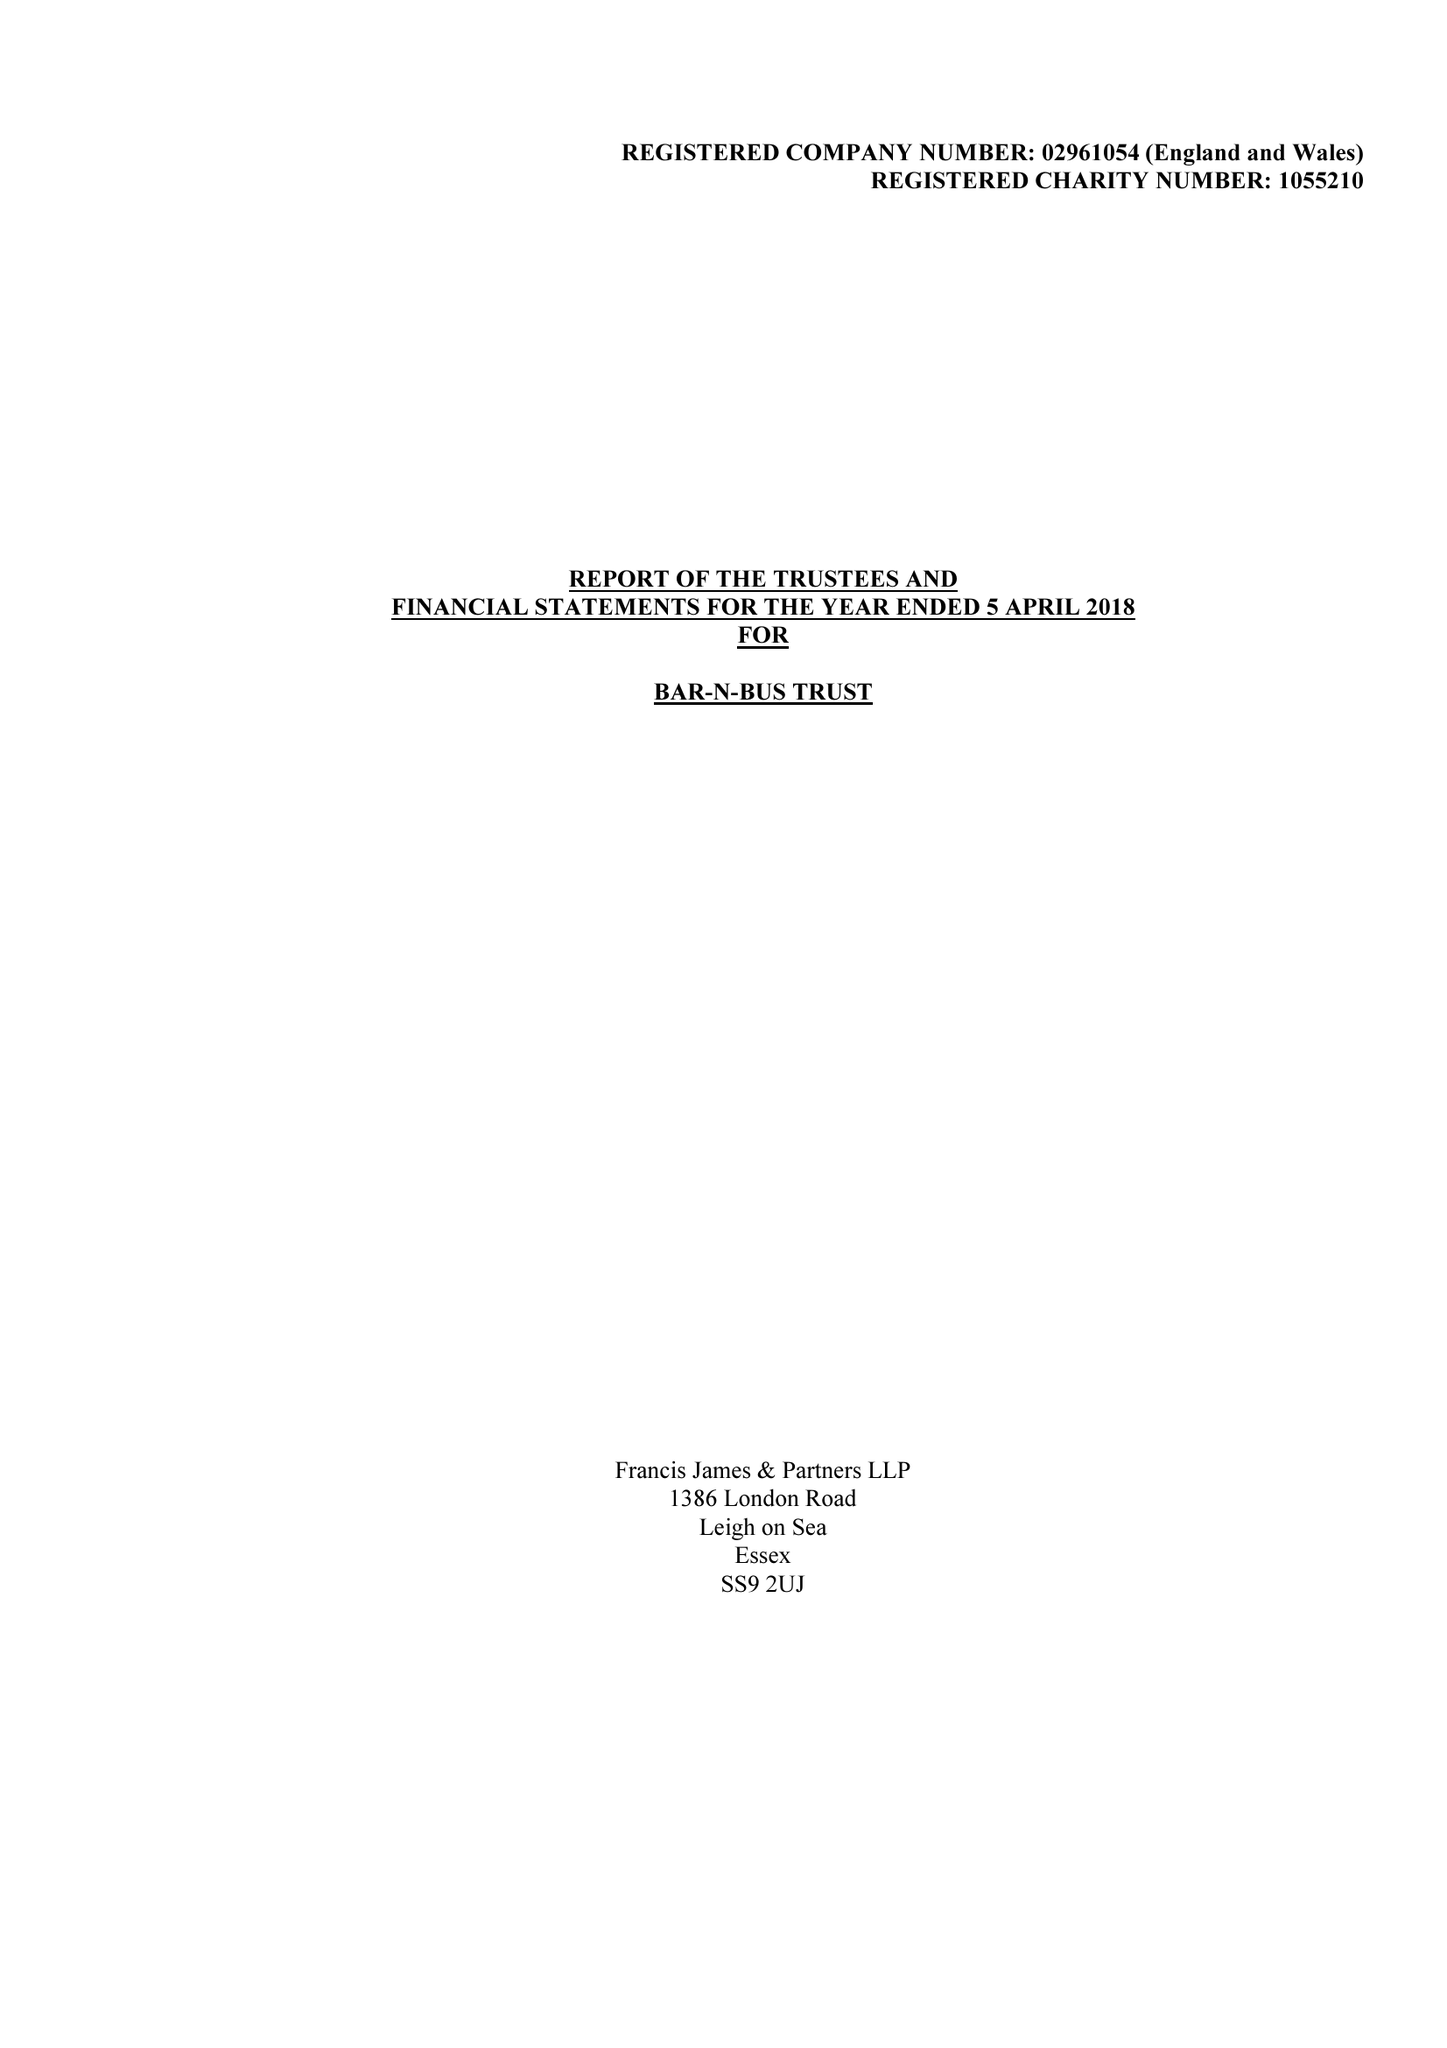What is the value for the charity_name?
Answer the question using a single word or phrase. Bar-N-Bus Trust 